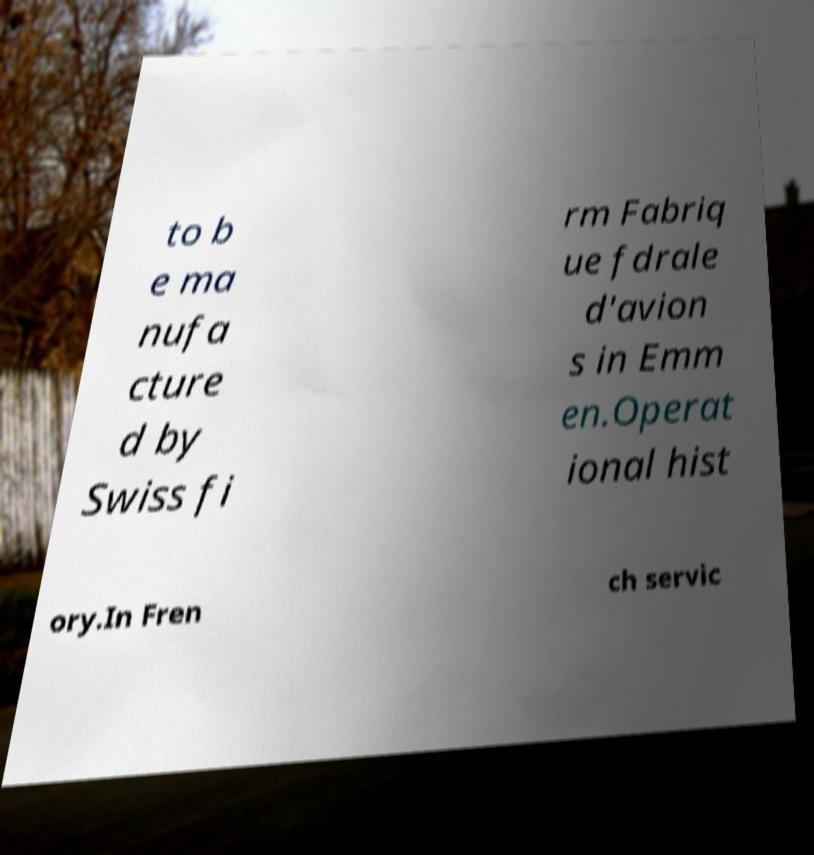Can you read and provide the text displayed in the image?This photo seems to have some interesting text. Can you extract and type it out for me? to b e ma nufa cture d by Swiss fi rm Fabriq ue fdrale d'avion s in Emm en.Operat ional hist ory.In Fren ch servic 